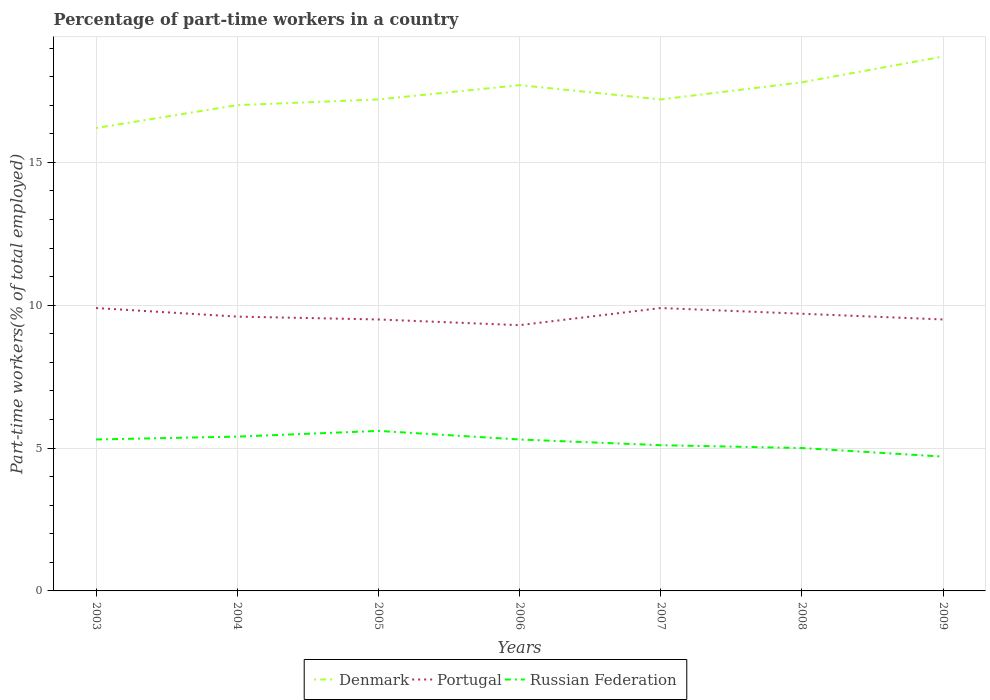Does the line corresponding to Portugal intersect with the line corresponding to Russian Federation?
Keep it short and to the point. No. Is the number of lines equal to the number of legend labels?
Provide a succinct answer. Yes. Across all years, what is the maximum percentage of part-time workers in Denmark?
Your answer should be very brief. 16.2. What is the total percentage of part-time workers in Portugal in the graph?
Provide a short and direct response. 0.3. What is the difference between the highest and the second highest percentage of part-time workers in Denmark?
Offer a terse response. 2.5. What is the difference between the highest and the lowest percentage of part-time workers in Portugal?
Provide a succinct answer. 3. What is the difference between two consecutive major ticks on the Y-axis?
Your answer should be compact. 5. Are the values on the major ticks of Y-axis written in scientific E-notation?
Offer a terse response. No. Does the graph contain grids?
Your answer should be very brief. Yes. What is the title of the graph?
Ensure brevity in your answer.  Percentage of part-time workers in a country. Does "Poland" appear as one of the legend labels in the graph?
Provide a short and direct response. No. What is the label or title of the Y-axis?
Your response must be concise. Part-time workers(% of total employed). What is the Part-time workers(% of total employed) of Denmark in 2003?
Provide a short and direct response. 16.2. What is the Part-time workers(% of total employed) of Portugal in 2003?
Offer a very short reply. 9.9. What is the Part-time workers(% of total employed) in Russian Federation in 2003?
Your answer should be compact. 5.3. What is the Part-time workers(% of total employed) of Denmark in 2004?
Your response must be concise. 17. What is the Part-time workers(% of total employed) in Portugal in 2004?
Give a very brief answer. 9.6. What is the Part-time workers(% of total employed) in Russian Federation in 2004?
Offer a terse response. 5.4. What is the Part-time workers(% of total employed) of Denmark in 2005?
Offer a very short reply. 17.2. What is the Part-time workers(% of total employed) in Russian Federation in 2005?
Provide a succinct answer. 5.6. What is the Part-time workers(% of total employed) of Denmark in 2006?
Give a very brief answer. 17.7. What is the Part-time workers(% of total employed) in Portugal in 2006?
Your response must be concise. 9.3. What is the Part-time workers(% of total employed) in Russian Federation in 2006?
Make the answer very short. 5.3. What is the Part-time workers(% of total employed) of Denmark in 2007?
Make the answer very short. 17.2. What is the Part-time workers(% of total employed) of Portugal in 2007?
Offer a terse response. 9.9. What is the Part-time workers(% of total employed) in Russian Federation in 2007?
Ensure brevity in your answer.  5.1. What is the Part-time workers(% of total employed) in Denmark in 2008?
Give a very brief answer. 17.8. What is the Part-time workers(% of total employed) of Portugal in 2008?
Give a very brief answer. 9.7. What is the Part-time workers(% of total employed) in Denmark in 2009?
Provide a succinct answer. 18.7. What is the Part-time workers(% of total employed) in Portugal in 2009?
Offer a terse response. 9.5. What is the Part-time workers(% of total employed) of Russian Federation in 2009?
Your answer should be compact. 4.7. Across all years, what is the maximum Part-time workers(% of total employed) of Denmark?
Offer a terse response. 18.7. Across all years, what is the maximum Part-time workers(% of total employed) in Portugal?
Offer a very short reply. 9.9. Across all years, what is the maximum Part-time workers(% of total employed) of Russian Federation?
Keep it short and to the point. 5.6. Across all years, what is the minimum Part-time workers(% of total employed) in Denmark?
Your response must be concise. 16.2. Across all years, what is the minimum Part-time workers(% of total employed) of Portugal?
Provide a succinct answer. 9.3. Across all years, what is the minimum Part-time workers(% of total employed) in Russian Federation?
Provide a short and direct response. 4.7. What is the total Part-time workers(% of total employed) in Denmark in the graph?
Provide a short and direct response. 121.8. What is the total Part-time workers(% of total employed) of Portugal in the graph?
Your response must be concise. 67.4. What is the total Part-time workers(% of total employed) in Russian Federation in the graph?
Provide a short and direct response. 36.4. What is the difference between the Part-time workers(% of total employed) of Denmark in 2003 and that in 2004?
Offer a very short reply. -0.8. What is the difference between the Part-time workers(% of total employed) in Russian Federation in 2003 and that in 2004?
Give a very brief answer. -0.1. What is the difference between the Part-time workers(% of total employed) of Denmark in 2003 and that in 2005?
Provide a succinct answer. -1. What is the difference between the Part-time workers(% of total employed) in Portugal in 2003 and that in 2005?
Make the answer very short. 0.4. What is the difference between the Part-time workers(% of total employed) in Denmark in 2003 and that in 2006?
Provide a short and direct response. -1.5. What is the difference between the Part-time workers(% of total employed) in Denmark in 2003 and that in 2007?
Provide a short and direct response. -1. What is the difference between the Part-time workers(% of total employed) of Russian Federation in 2003 and that in 2007?
Your response must be concise. 0.2. What is the difference between the Part-time workers(% of total employed) of Portugal in 2003 and that in 2008?
Your response must be concise. 0.2. What is the difference between the Part-time workers(% of total employed) in Denmark in 2004 and that in 2005?
Offer a terse response. -0.2. What is the difference between the Part-time workers(% of total employed) of Portugal in 2004 and that in 2005?
Provide a short and direct response. 0.1. What is the difference between the Part-time workers(% of total employed) of Russian Federation in 2004 and that in 2005?
Provide a short and direct response. -0.2. What is the difference between the Part-time workers(% of total employed) of Portugal in 2004 and that in 2006?
Your answer should be compact. 0.3. What is the difference between the Part-time workers(% of total employed) in Russian Federation in 2004 and that in 2006?
Offer a terse response. 0.1. What is the difference between the Part-time workers(% of total employed) in Portugal in 2004 and that in 2008?
Offer a very short reply. -0.1. What is the difference between the Part-time workers(% of total employed) in Denmark in 2004 and that in 2009?
Provide a short and direct response. -1.7. What is the difference between the Part-time workers(% of total employed) in Portugal in 2004 and that in 2009?
Provide a short and direct response. 0.1. What is the difference between the Part-time workers(% of total employed) of Portugal in 2005 and that in 2006?
Make the answer very short. 0.2. What is the difference between the Part-time workers(% of total employed) of Denmark in 2005 and that in 2007?
Provide a succinct answer. 0. What is the difference between the Part-time workers(% of total employed) in Portugal in 2005 and that in 2007?
Ensure brevity in your answer.  -0.4. What is the difference between the Part-time workers(% of total employed) of Portugal in 2005 and that in 2008?
Your response must be concise. -0.2. What is the difference between the Part-time workers(% of total employed) of Russian Federation in 2005 and that in 2008?
Offer a very short reply. 0.6. What is the difference between the Part-time workers(% of total employed) in Denmark in 2006 and that in 2007?
Provide a short and direct response. 0.5. What is the difference between the Part-time workers(% of total employed) in Portugal in 2006 and that in 2007?
Give a very brief answer. -0.6. What is the difference between the Part-time workers(% of total employed) of Russian Federation in 2006 and that in 2008?
Offer a terse response. 0.3. What is the difference between the Part-time workers(% of total employed) in Denmark in 2006 and that in 2009?
Ensure brevity in your answer.  -1. What is the difference between the Part-time workers(% of total employed) of Portugal in 2007 and that in 2008?
Provide a succinct answer. 0.2. What is the difference between the Part-time workers(% of total employed) in Russian Federation in 2007 and that in 2008?
Provide a succinct answer. 0.1. What is the difference between the Part-time workers(% of total employed) of Denmark in 2007 and that in 2009?
Give a very brief answer. -1.5. What is the difference between the Part-time workers(% of total employed) of Portugal in 2007 and that in 2009?
Ensure brevity in your answer.  0.4. What is the difference between the Part-time workers(% of total employed) of Russian Federation in 2007 and that in 2009?
Your answer should be very brief. 0.4. What is the difference between the Part-time workers(% of total employed) in Denmark in 2008 and that in 2009?
Your answer should be very brief. -0.9. What is the difference between the Part-time workers(% of total employed) of Russian Federation in 2008 and that in 2009?
Make the answer very short. 0.3. What is the difference between the Part-time workers(% of total employed) of Denmark in 2003 and the Part-time workers(% of total employed) of Russian Federation in 2004?
Offer a terse response. 10.8. What is the difference between the Part-time workers(% of total employed) in Portugal in 2003 and the Part-time workers(% of total employed) in Russian Federation in 2004?
Your answer should be very brief. 4.5. What is the difference between the Part-time workers(% of total employed) in Denmark in 2003 and the Part-time workers(% of total employed) in Portugal in 2005?
Make the answer very short. 6.7. What is the difference between the Part-time workers(% of total employed) in Denmark in 2003 and the Part-time workers(% of total employed) in Russian Federation in 2005?
Offer a very short reply. 10.6. What is the difference between the Part-time workers(% of total employed) in Portugal in 2003 and the Part-time workers(% of total employed) in Russian Federation in 2005?
Your answer should be compact. 4.3. What is the difference between the Part-time workers(% of total employed) in Denmark in 2003 and the Part-time workers(% of total employed) in Russian Federation in 2006?
Your answer should be very brief. 10.9. What is the difference between the Part-time workers(% of total employed) in Denmark in 2003 and the Part-time workers(% of total employed) in Portugal in 2007?
Provide a succinct answer. 6.3. What is the difference between the Part-time workers(% of total employed) in Portugal in 2003 and the Part-time workers(% of total employed) in Russian Federation in 2007?
Keep it short and to the point. 4.8. What is the difference between the Part-time workers(% of total employed) in Portugal in 2003 and the Part-time workers(% of total employed) in Russian Federation in 2008?
Your response must be concise. 4.9. What is the difference between the Part-time workers(% of total employed) in Denmark in 2004 and the Part-time workers(% of total employed) in Portugal in 2005?
Keep it short and to the point. 7.5. What is the difference between the Part-time workers(% of total employed) in Denmark in 2004 and the Part-time workers(% of total employed) in Russian Federation in 2005?
Your answer should be very brief. 11.4. What is the difference between the Part-time workers(% of total employed) of Portugal in 2004 and the Part-time workers(% of total employed) of Russian Federation in 2006?
Your response must be concise. 4.3. What is the difference between the Part-time workers(% of total employed) of Portugal in 2004 and the Part-time workers(% of total employed) of Russian Federation in 2007?
Ensure brevity in your answer.  4.5. What is the difference between the Part-time workers(% of total employed) of Portugal in 2004 and the Part-time workers(% of total employed) of Russian Federation in 2008?
Keep it short and to the point. 4.6. What is the difference between the Part-time workers(% of total employed) in Denmark in 2005 and the Part-time workers(% of total employed) in Russian Federation in 2006?
Your answer should be compact. 11.9. What is the difference between the Part-time workers(% of total employed) of Denmark in 2005 and the Part-time workers(% of total employed) of Russian Federation in 2007?
Make the answer very short. 12.1. What is the difference between the Part-time workers(% of total employed) in Portugal in 2005 and the Part-time workers(% of total employed) in Russian Federation in 2007?
Keep it short and to the point. 4.4. What is the difference between the Part-time workers(% of total employed) of Denmark in 2005 and the Part-time workers(% of total employed) of Portugal in 2008?
Your answer should be very brief. 7.5. What is the difference between the Part-time workers(% of total employed) in Denmark in 2005 and the Part-time workers(% of total employed) in Russian Federation in 2008?
Make the answer very short. 12.2. What is the difference between the Part-time workers(% of total employed) in Denmark in 2005 and the Part-time workers(% of total employed) in Portugal in 2009?
Ensure brevity in your answer.  7.7. What is the difference between the Part-time workers(% of total employed) in Portugal in 2005 and the Part-time workers(% of total employed) in Russian Federation in 2009?
Offer a very short reply. 4.8. What is the difference between the Part-time workers(% of total employed) of Denmark in 2006 and the Part-time workers(% of total employed) of Russian Federation in 2007?
Ensure brevity in your answer.  12.6. What is the difference between the Part-time workers(% of total employed) of Portugal in 2006 and the Part-time workers(% of total employed) of Russian Federation in 2007?
Your answer should be very brief. 4.2. What is the difference between the Part-time workers(% of total employed) of Denmark in 2006 and the Part-time workers(% of total employed) of Russian Federation in 2008?
Provide a short and direct response. 12.7. What is the difference between the Part-time workers(% of total employed) of Denmark in 2006 and the Part-time workers(% of total employed) of Russian Federation in 2009?
Your answer should be very brief. 13. What is the difference between the Part-time workers(% of total employed) of Portugal in 2006 and the Part-time workers(% of total employed) of Russian Federation in 2009?
Ensure brevity in your answer.  4.6. What is the difference between the Part-time workers(% of total employed) of Denmark in 2007 and the Part-time workers(% of total employed) of Russian Federation in 2008?
Offer a terse response. 12.2. What is the difference between the Part-time workers(% of total employed) of Denmark in 2007 and the Part-time workers(% of total employed) of Portugal in 2009?
Your response must be concise. 7.7. What is the difference between the Part-time workers(% of total employed) of Denmark in 2007 and the Part-time workers(% of total employed) of Russian Federation in 2009?
Your answer should be very brief. 12.5. What is the difference between the Part-time workers(% of total employed) in Portugal in 2007 and the Part-time workers(% of total employed) in Russian Federation in 2009?
Provide a succinct answer. 5.2. What is the difference between the Part-time workers(% of total employed) of Denmark in 2008 and the Part-time workers(% of total employed) of Portugal in 2009?
Your answer should be compact. 8.3. What is the difference between the Part-time workers(% of total employed) in Portugal in 2008 and the Part-time workers(% of total employed) in Russian Federation in 2009?
Offer a very short reply. 5. What is the average Part-time workers(% of total employed) in Denmark per year?
Give a very brief answer. 17.4. What is the average Part-time workers(% of total employed) in Portugal per year?
Keep it short and to the point. 9.63. In the year 2003, what is the difference between the Part-time workers(% of total employed) in Denmark and Part-time workers(% of total employed) in Portugal?
Offer a terse response. 6.3. In the year 2003, what is the difference between the Part-time workers(% of total employed) in Portugal and Part-time workers(% of total employed) in Russian Federation?
Your response must be concise. 4.6. In the year 2004, what is the difference between the Part-time workers(% of total employed) in Denmark and Part-time workers(% of total employed) in Portugal?
Give a very brief answer. 7.4. In the year 2004, what is the difference between the Part-time workers(% of total employed) of Portugal and Part-time workers(% of total employed) of Russian Federation?
Provide a short and direct response. 4.2. In the year 2005, what is the difference between the Part-time workers(% of total employed) in Denmark and Part-time workers(% of total employed) in Russian Federation?
Keep it short and to the point. 11.6. In the year 2005, what is the difference between the Part-time workers(% of total employed) in Portugal and Part-time workers(% of total employed) in Russian Federation?
Provide a short and direct response. 3.9. In the year 2006, what is the difference between the Part-time workers(% of total employed) in Denmark and Part-time workers(% of total employed) in Portugal?
Offer a terse response. 8.4. In the year 2007, what is the difference between the Part-time workers(% of total employed) of Denmark and Part-time workers(% of total employed) of Russian Federation?
Keep it short and to the point. 12.1. In the year 2008, what is the difference between the Part-time workers(% of total employed) in Denmark and Part-time workers(% of total employed) in Portugal?
Your response must be concise. 8.1. In the year 2008, what is the difference between the Part-time workers(% of total employed) in Portugal and Part-time workers(% of total employed) in Russian Federation?
Keep it short and to the point. 4.7. What is the ratio of the Part-time workers(% of total employed) in Denmark in 2003 to that in 2004?
Your response must be concise. 0.95. What is the ratio of the Part-time workers(% of total employed) in Portugal in 2003 to that in 2004?
Provide a short and direct response. 1.03. What is the ratio of the Part-time workers(% of total employed) of Russian Federation in 2003 to that in 2004?
Ensure brevity in your answer.  0.98. What is the ratio of the Part-time workers(% of total employed) in Denmark in 2003 to that in 2005?
Provide a short and direct response. 0.94. What is the ratio of the Part-time workers(% of total employed) in Portugal in 2003 to that in 2005?
Offer a very short reply. 1.04. What is the ratio of the Part-time workers(% of total employed) of Russian Federation in 2003 to that in 2005?
Your answer should be compact. 0.95. What is the ratio of the Part-time workers(% of total employed) of Denmark in 2003 to that in 2006?
Keep it short and to the point. 0.92. What is the ratio of the Part-time workers(% of total employed) of Portugal in 2003 to that in 2006?
Offer a very short reply. 1.06. What is the ratio of the Part-time workers(% of total employed) in Russian Federation in 2003 to that in 2006?
Ensure brevity in your answer.  1. What is the ratio of the Part-time workers(% of total employed) in Denmark in 2003 to that in 2007?
Your answer should be very brief. 0.94. What is the ratio of the Part-time workers(% of total employed) in Russian Federation in 2003 to that in 2007?
Keep it short and to the point. 1.04. What is the ratio of the Part-time workers(% of total employed) in Denmark in 2003 to that in 2008?
Ensure brevity in your answer.  0.91. What is the ratio of the Part-time workers(% of total employed) in Portugal in 2003 to that in 2008?
Offer a very short reply. 1.02. What is the ratio of the Part-time workers(% of total employed) in Russian Federation in 2003 to that in 2008?
Provide a succinct answer. 1.06. What is the ratio of the Part-time workers(% of total employed) of Denmark in 2003 to that in 2009?
Make the answer very short. 0.87. What is the ratio of the Part-time workers(% of total employed) in Portugal in 2003 to that in 2009?
Your answer should be compact. 1.04. What is the ratio of the Part-time workers(% of total employed) in Russian Federation in 2003 to that in 2009?
Offer a very short reply. 1.13. What is the ratio of the Part-time workers(% of total employed) of Denmark in 2004 to that in 2005?
Offer a very short reply. 0.99. What is the ratio of the Part-time workers(% of total employed) in Portugal in 2004 to that in 2005?
Your answer should be very brief. 1.01. What is the ratio of the Part-time workers(% of total employed) in Denmark in 2004 to that in 2006?
Give a very brief answer. 0.96. What is the ratio of the Part-time workers(% of total employed) in Portugal in 2004 to that in 2006?
Ensure brevity in your answer.  1.03. What is the ratio of the Part-time workers(% of total employed) of Russian Federation in 2004 to that in 2006?
Your answer should be very brief. 1.02. What is the ratio of the Part-time workers(% of total employed) in Denmark in 2004 to that in 2007?
Your answer should be compact. 0.99. What is the ratio of the Part-time workers(% of total employed) of Portugal in 2004 to that in 2007?
Your response must be concise. 0.97. What is the ratio of the Part-time workers(% of total employed) of Russian Federation in 2004 to that in 2007?
Offer a terse response. 1.06. What is the ratio of the Part-time workers(% of total employed) of Denmark in 2004 to that in 2008?
Provide a succinct answer. 0.96. What is the ratio of the Part-time workers(% of total employed) of Portugal in 2004 to that in 2009?
Provide a short and direct response. 1.01. What is the ratio of the Part-time workers(% of total employed) in Russian Federation in 2004 to that in 2009?
Your answer should be very brief. 1.15. What is the ratio of the Part-time workers(% of total employed) in Denmark in 2005 to that in 2006?
Your response must be concise. 0.97. What is the ratio of the Part-time workers(% of total employed) of Portugal in 2005 to that in 2006?
Give a very brief answer. 1.02. What is the ratio of the Part-time workers(% of total employed) in Russian Federation in 2005 to that in 2006?
Offer a very short reply. 1.06. What is the ratio of the Part-time workers(% of total employed) in Denmark in 2005 to that in 2007?
Make the answer very short. 1. What is the ratio of the Part-time workers(% of total employed) of Portugal in 2005 to that in 2007?
Your answer should be compact. 0.96. What is the ratio of the Part-time workers(% of total employed) in Russian Federation in 2005 to that in 2007?
Your answer should be compact. 1.1. What is the ratio of the Part-time workers(% of total employed) in Denmark in 2005 to that in 2008?
Offer a very short reply. 0.97. What is the ratio of the Part-time workers(% of total employed) in Portugal in 2005 to that in 2008?
Your answer should be compact. 0.98. What is the ratio of the Part-time workers(% of total employed) of Russian Federation in 2005 to that in 2008?
Provide a succinct answer. 1.12. What is the ratio of the Part-time workers(% of total employed) of Denmark in 2005 to that in 2009?
Offer a very short reply. 0.92. What is the ratio of the Part-time workers(% of total employed) in Russian Federation in 2005 to that in 2009?
Make the answer very short. 1.19. What is the ratio of the Part-time workers(% of total employed) of Denmark in 2006 to that in 2007?
Offer a very short reply. 1.03. What is the ratio of the Part-time workers(% of total employed) of Portugal in 2006 to that in 2007?
Your response must be concise. 0.94. What is the ratio of the Part-time workers(% of total employed) in Russian Federation in 2006 to that in 2007?
Make the answer very short. 1.04. What is the ratio of the Part-time workers(% of total employed) in Portugal in 2006 to that in 2008?
Make the answer very short. 0.96. What is the ratio of the Part-time workers(% of total employed) of Russian Federation in 2006 to that in 2008?
Your response must be concise. 1.06. What is the ratio of the Part-time workers(% of total employed) of Denmark in 2006 to that in 2009?
Ensure brevity in your answer.  0.95. What is the ratio of the Part-time workers(% of total employed) of Portugal in 2006 to that in 2009?
Offer a terse response. 0.98. What is the ratio of the Part-time workers(% of total employed) in Russian Federation in 2006 to that in 2009?
Your answer should be very brief. 1.13. What is the ratio of the Part-time workers(% of total employed) of Denmark in 2007 to that in 2008?
Offer a very short reply. 0.97. What is the ratio of the Part-time workers(% of total employed) in Portugal in 2007 to that in 2008?
Provide a short and direct response. 1.02. What is the ratio of the Part-time workers(% of total employed) of Denmark in 2007 to that in 2009?
Ensure brevity in your answer.  0.92. What is the ratio of the Part-time workers(% of total employed) in Portugal in 2007 to that in 2009?
Your answer should be very brief. 1.04. What is the ratio of the Part-time workers(% of total employed) of Russian Federation in 2007 to that in 2009?
Your answer should be compact. 1.09. What is the ratio of the Part-time workers(% of total employed) in Denmark in 2008 to that in 2009?
Your answer should be compact. 0.95. What is the ratio of the Part-time workers(% of total employed) of Portugal in 2008 to that in 2009?
Keep it short and to the point. 1.02. What is the ratio of the Part-time workers(% of total employed) in Russian Federation in 2008 to that in 2009?
Provide a short and direct response. 1.06. What is the difference between the highest and the second highest Part-time workers(% of total employed) of Russian Federation?
Offer a terse response. 0.2. What is the difference between the highest and the lowest Part-time workers(% of total employed) of Denmark?
Offer a terse response. 2.5. What is the difference between the highest and the lowest Part-time workers(% of total employed) of Russian Federation?
Your answer should be very brief. 0.9. 